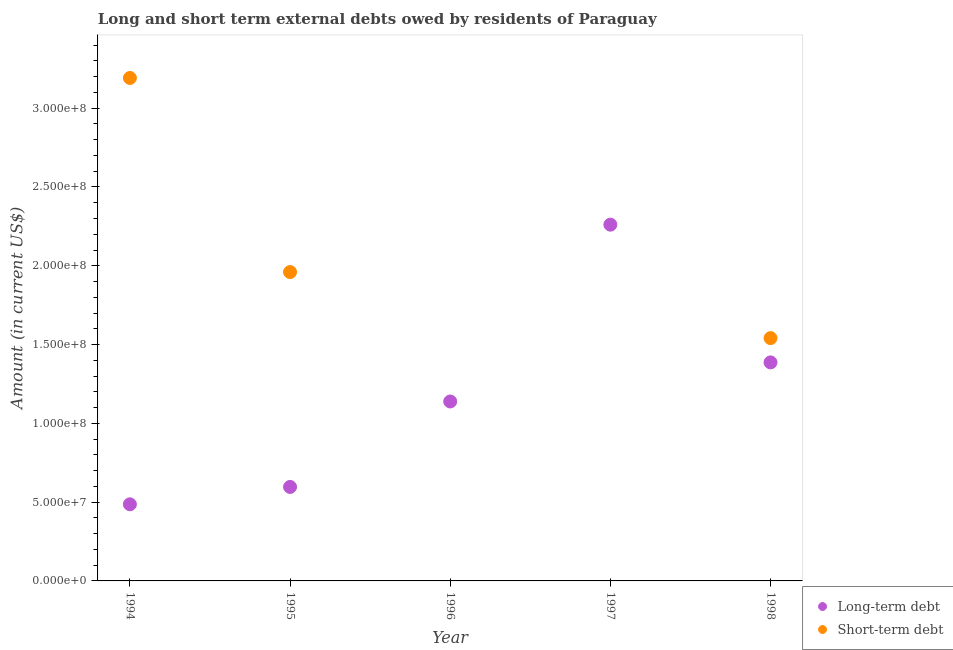Is the number of dotlines equal to the number of legend labels?
Your response must be concise. No. Across all years, what is the maximum long-term debts owed by residents?
Your answer should be very brief. 2.26e+08. Across all years, what is the minimum long-term debts owed by residents?
Provide a short and direct response. 4.86e+07. In which year was the long-term debts owed by residents maximum?
Keep it short and to the point. 1997. What is the total long-term debts owed by residents in the graph?
Keep it short and to the point. 5.87e+08. What is the difference between the long-term debts owed by residents in 1994 and that in 1995?
Your answer should be compact. -1.10e+07. What is the difference between the long-term debts owed by residents in 1997 and the short-term debts owed by residents in 1996?
Offer a terse response. 2.26e+08. What is the average long-term debts owed by residents per year?
Provide a succinct answer. 1.17e+08. In the year 1994, what is the difference between the long-term debts owed by residents and short-term debts owed by residents?
Your answer should be very brief. -2.71e+08. What is the ratio of the long-term debts owed by residents in 1995 to that in 1997?
Make the answer very short. 0.26. Is the long-term debts owed by residents in 1996 less than that in 1997?
Your answer should be compact. Yes. What is the difference between the highest and the second highest short-term debts owed by residents?
Provide a short and direct response. 1.23e+08. What is the difference between the highest and the lowest short-term debts owed by residents?
Offer a very short reply. 3.19e+08. Is the sum of the long-term debts owed by residents in 1994 and 1998 greater than the maximum short-term debts owed by residents across all years?
Provide a succinct answer. No. Is the long-term debts owed by residents strictly greater than the short-term debts owed by residents over the years?
Keep it short and to the point. No. How many years are there in the graph?
Your answer should be compact. 5. Does the graph contain grids?
Offer a terse response. No. How are the legend labels stacked?
Your answer should be very brief. Vertical. What is the title of the graph?
Your answer should be compact. Long and short term external debts owed by residents of Paraguay. Does "Investment" appear as one of the legend labels in the graph?
Keep it short and to the point. No. What is the label or title of the X-axis?
Offer a terse response. Year. What is the label or title of the Y-axis?
Provide a succinct answer. Amount (in current US$). What is the Amount (in current US$) of Long-term debt in 1994?
Keep it short and to the point. 4.86e+07. What is the Amount (in current US$) in Short-term debt in 1994?
Offer a very short reply. 3.19e+08. What is the Amount (in current US$) in Long-term debt in 1995?
Offer a very short reply. 5.97e+07. What is the Amount (in current US$) of Short-term debt in 1995?
Provide a succinct answer. 1.96e+08. What is the Amount (in current US$) of Long-term debt in 1996?
Your answer should be compact. 1.14e+08. What is the Amount (in current US$) of Long-term debt in 1997?
Your response must be concise. 2.26e+08. What is the Amount (in current US$) of Short-term debt in 1997?
Provide a succinct answer. 0. What is the Amount (in current US$) in Long-term debt in 1998?
Provide a succinct answer. 1.39e+08. What is the Amount (in current US$) of Short-term debt in 1998?
Your answer should be very brief. 1.54e+08. Across all years, what is the maximum Amount (in current US$) in Long-term debt?
Provide a succinct answer. 2.26e+08. Across all years, what is the maximum Amount (in current US$) of Short-term debt?
Your response must be concise. 3.19e+08. Across all years, what is the minimum Amount (in current US$) of Long-term debt?
Ensure brevity in your answer.  4.86e+07. What is the total Amount (in current US$) in Long-term debt in the graph?
Your answer should be compact. 5.87e+08. What is the total Amount (in current US$) in Short-term debt in the graph?
Your answer should be compact. 6.69e+08. What is the difference between the Amount (in current US$) in Long-term debt in 1994 and that in 1995?
Offer a terse response. -1.10e+07. What is the difference between the Amount (in current US$) of Short-term debt in 1994 and that in 1995?
Your response must be concise. 1.23e+08. What is the difference between the Amount (in current US$) of Long-term debt in 1994 and that in 1996?
Give a very brief answer. -6.53e+07. What is the difference between the Amount (in current US$) of Long-term debt in 1994 and that in 1997?
Offer a very short reply. -1.77e+08. What is the difference between the Amount (in current US$) in Long-term debt in 1994 and that in 1998?
Give a very brief answer. -9.01e+07. What is the difference between the Amount (in current US$) of Short-term debt in 1994 and that in 1998?
Ensure brevity in your answer.  1.65e+08. What is the difference between the Amount (in current US$) of Long-term debt in 1995 and that in 1996?
Your response must be concise. -5.42e+07. What is the difference between the Amount (in current US$) of Long-term debt in 1995 and that in 1997?
Ensure brevity in your answer.  -1.66e+08. What is the difference between the Amount (in current US$) in Long-term debt in 1995 and that in 1998?
Offer a very short reply. -7.90e+07. What is the difference between the Amount (in current US$) in Short-term debt in 1995 and that in 1998?
Keep it short and to the point. 4.19e+07. What is the difference between the Amount (in current US$) of Long-term debt in 1996 and that in 1997?
Provide a succinct answer. -1.12e+08. What is the difference between the Amount (in current US$) of Long-term debt in 1996 and that in 1998?
Keep it short and to the point. -2.48e+07. What is the difference between the Amount (in current US$) in Long-term debt in 1997 and that in 1998?
Your answer should be very brief. 8.74e+07. What is the difference between the Amount (in current US$) in Long-term debt in 1994 and the Amount (in current US$) in Short-term debt in 1995?
Keep it short and to the point. -1.47e+08. What is the difference between the Amount (in current US$) in Long-term debt in 1994 and the Amount (in current US$) in Short-term debt in 1998?
Make the answer very short. -1.05e+08. What is the difference between the Amount (in current US$) in Long-term debt in 1995 and the Amount (in current US$) in Short-term debt in 1998?
Provide a short and direct response. -9.44e+07. What is the difference between the Amount (in current US$) in Long-term debt in 1996 and the Amount (in current US$) in Short-term debt in 1998?
Your answer should be very brief. -4.02e+07. What is the difference between the Amount (in current US$) in Long-term debt in 1997 and the Amount (in current US$) in Short-term debt in 1998?
Offer a terse response. 7.20e+07. What is the average Amount (in current US$) in Long-term debt per year?
Ensure brevity in your answer.  1.17e+08. What is the average Amount (in current US$) of Short-term debt per year?
Keep it short and to the point. 1.34e+08. In the year 1994, what is the difference between the Amount (in current US$) of Long-term debt and Amount (in current US$) of Short-term debt?
Provide a short and direct response. -2.71e+08. In the year 1995, what is the difference between the Amount (in current US$) of Long-term debt and Amount (in current US$) of Short-term debt?
Give a very brief answer. -1.36e+08. In the year 1998, what is the difference between the Amount (in current US$) of Long-term debt and Amount (in current US$) of Short-term debt?
Ensure brevity in your answer.  -1.54e+07. What is the ratio of the Amount (in current US$) of Long-term debt in 1994 to that in 1995?
Keep it short and to the point. 0.82. What is the ratio of the Amount (in current US$) in Short-term debt in 1994 to that in 1995?
Give a very brief answer. 1.63. What is the ratio of the Amount (in current US$) in Long-term debt in 1994 to that in 1996?
Provide a short and direct response. 0.43. What is the ratio of the Amount (in current US$) of Long-term debt in 1994 to that in 1997?
Provide a short and direct response. 0.22. What is the ratio of the Amount (in current US$) of Long-term debt in 1994 to that in 1998?
Provide a short and direct response. 0.35. What is the ratio of the Amount (in current US$) in Short-term debt in 1994 to that in 1998?
Make the answer very short. 2.07. What is the ratio of the Amount (in current US$) of Long-term debt in 1995 to that in 1996?
Keep it short and to the point. 0.52. What is the ratio of the Amount (in current US$) of Long-term debt in 1995 to that in 1997?
Your response must be concise. 0.26. What is the ratio of the Amount (in current US$) of Long-term debt in 1995 to that in 1998?
Your answer should be compact. 0.43. What is the ratio of the Amount (in current US$) in Short-term debt in 1995 to that in 1998?
Offer a terse response. 1.27. What is the ratio of the Amount (in current US$) of Long-term debt in 1996 to that in 1997?
Give a very brief answer. 0.5. What is the ratio of the Amount (in current US$) of Long-term debt in 1996 to that in 1998?
Your answer should be very brief. 0.82. What is the ratio of the Amount (in current US$) in Long-term debt in 1997 to that in 1998?
Your response must be concise. 1.63. What is the difference between the highest and the second highest Amount (in current US$) of Long-term debt?
Your response must be concise. 8.74e+07. What is the difference between the highest and the second highest Amount (in current US$) in Short-term debt?
Ensure brevity in your answer.  1.23e+08. What is the difference between the highest and the lowest Amount (in current US$) in Long-term debt?
Your answer should be compact. 1.77e+08. What is the difference between the highest and the lowest Amount (in current US$) in Short-term debt?
Keep it short and to the point. 3.19e+08. 